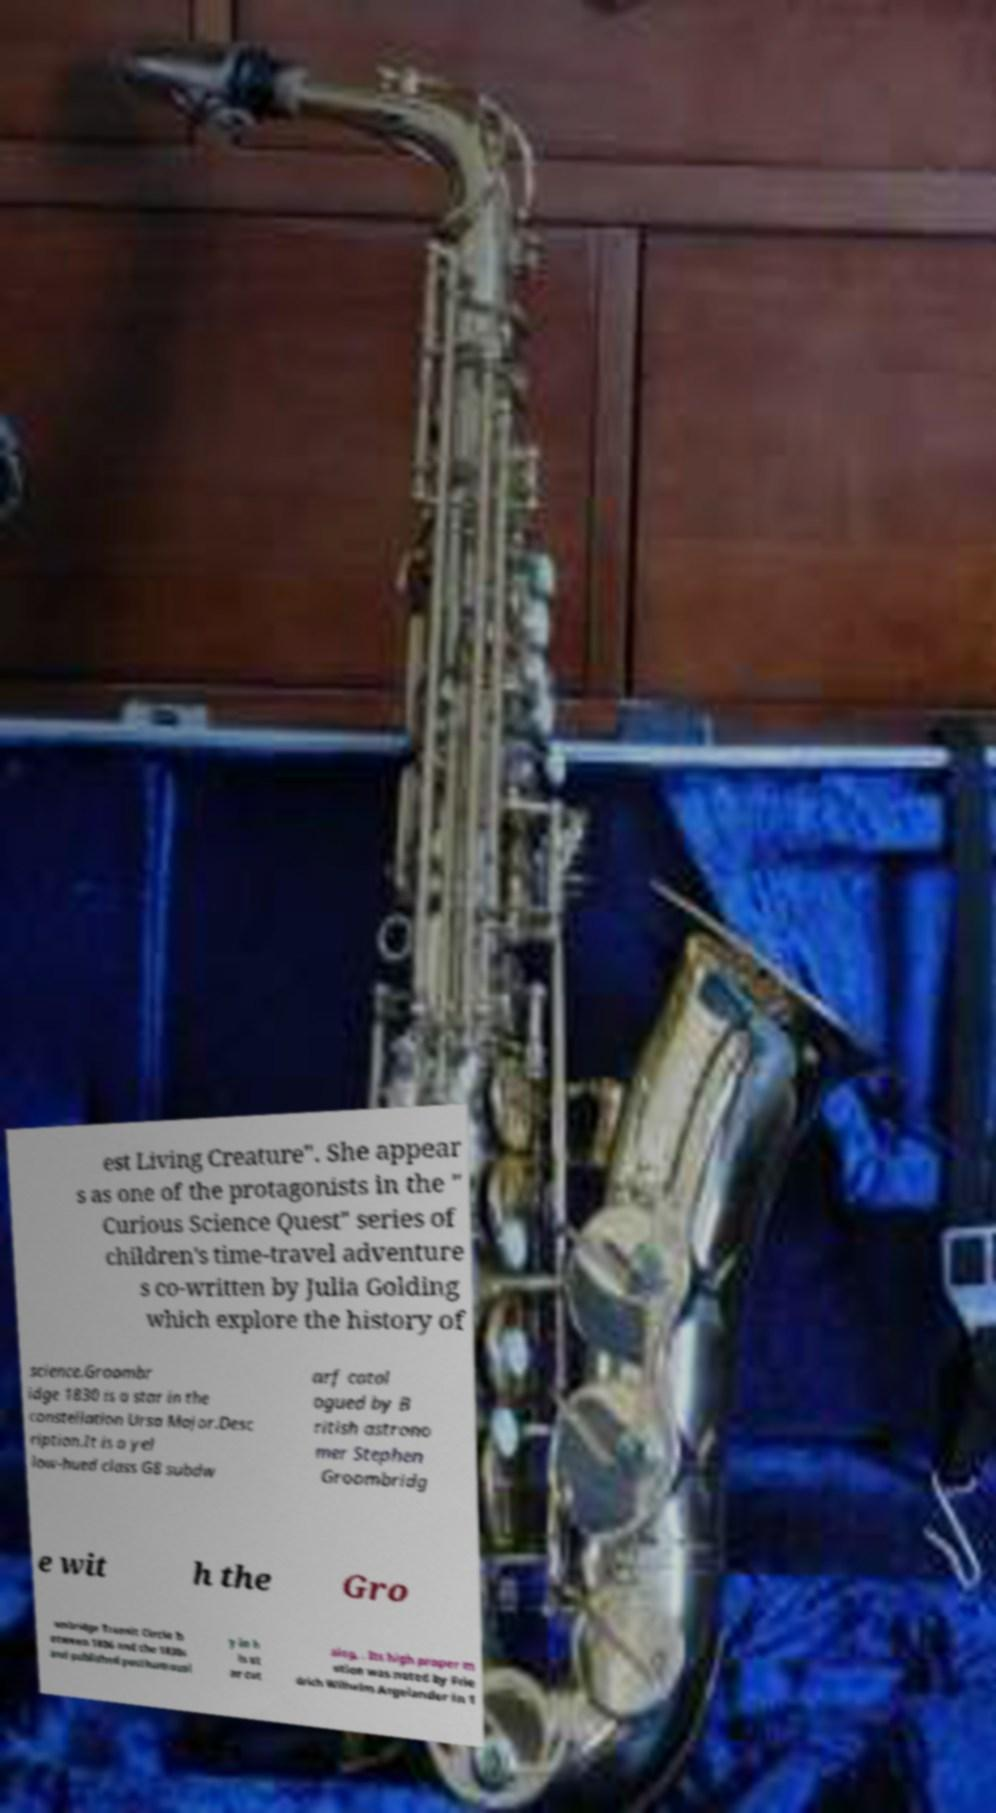I need the written content from this picture converted into text. Can you do that? est Living Creature". She appear s as one of the protagonists in the " Curious Science Quest" series of children's time-travel adventure s co-written by Julia Golding which explore the history of science.Groombr idge 1830 is a star in the constellation Ursa Major.Desc ription.It is a yel low-hued class G8 subdw arf catal ogued by B ritish astrono mer Stephen Groombridg e wit h the Gro ombridge Transit Circle b etween 1806 and the 1830s and published posthumousl y in h is st ar cat alog, . Its high proper m otion was noted by Frie drich Wilhelm Argelander in 1 